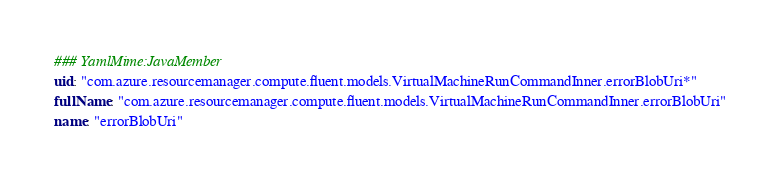<code> <loc_0><loc_0><loc_500><loc_500><_YAML_>### YamlMime:JavaMember
uid: "com.azure.resourcemanager.compute.fluent.models.VirtualMachineRunCommandInner.errorBlobUri*"
fullName: "com.azure.resourcemanager.compute.fluent.models.VirtualMachineRunCommandInner.errorBlobUri"
name: "errorBlobUri"</code> 